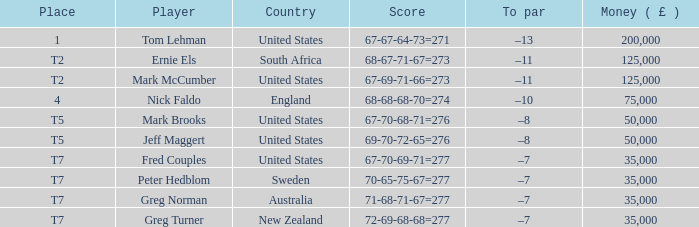What is the to par value, when the player is "greg turner"? –7. 